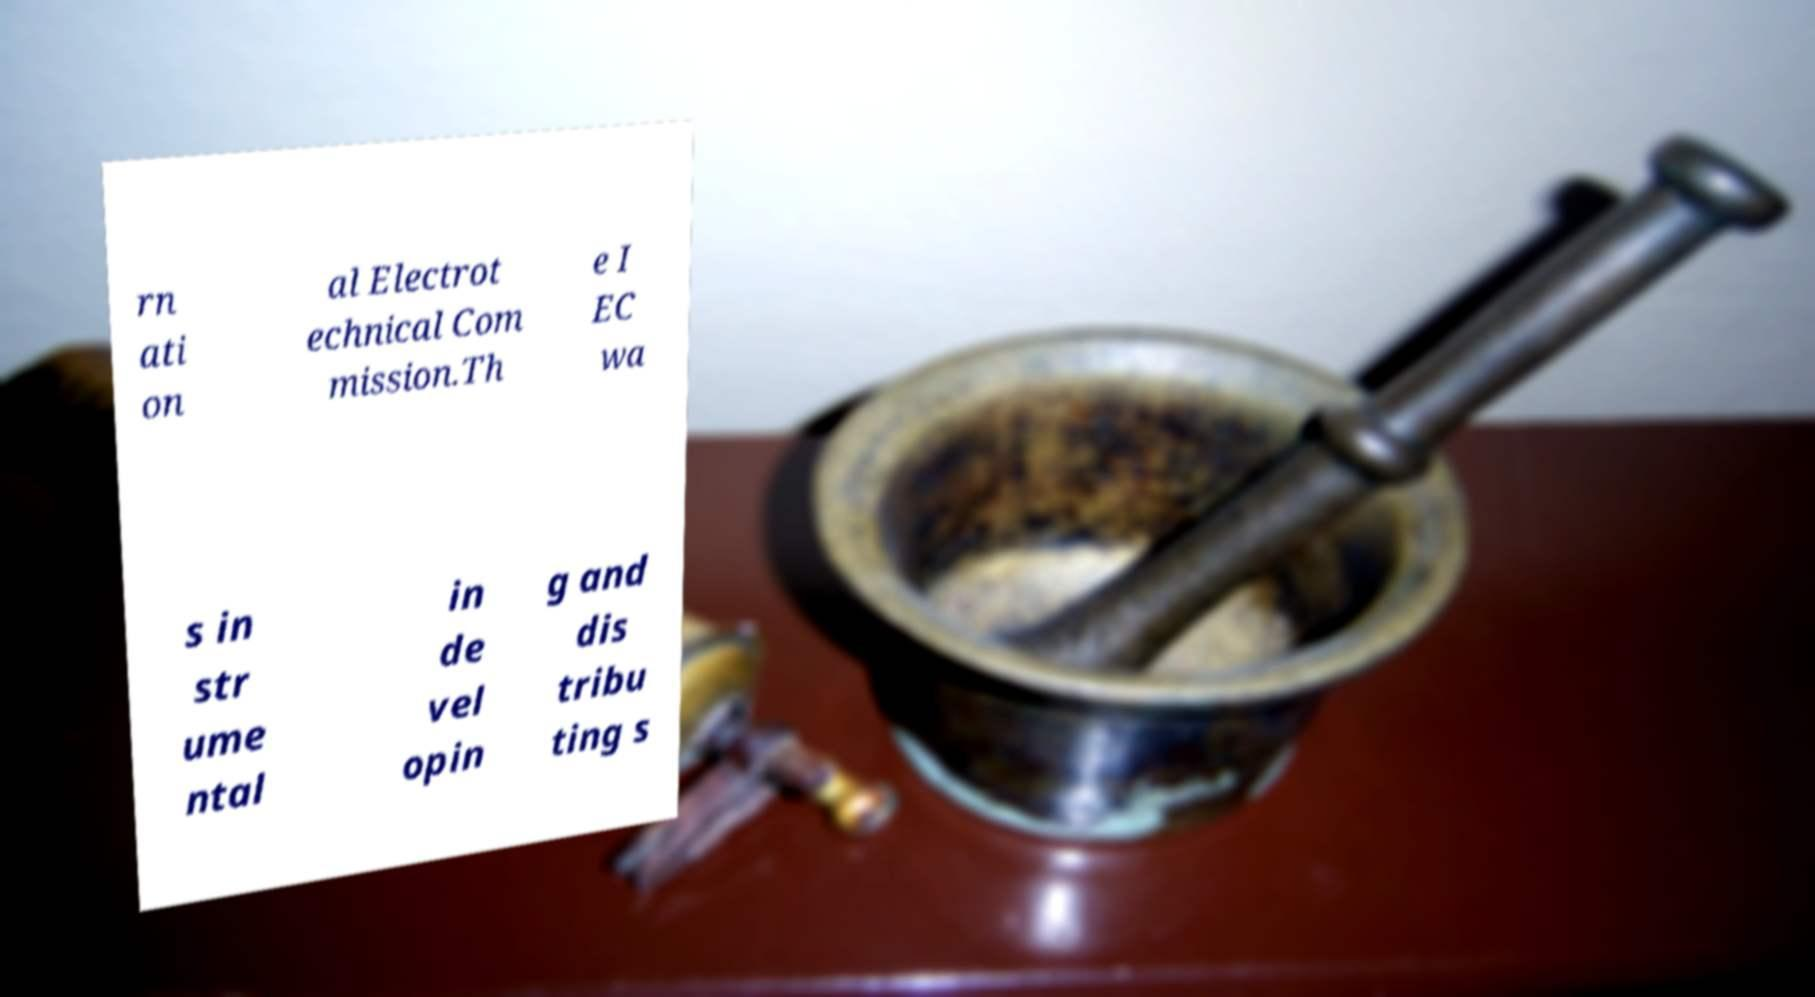Can you accurately transcribe the text from the provided image for me? rn ati on al Electrot echnical Com mission.Th e I EC wa s in str ume ntal in de vel opin g and dis tribu ting s 